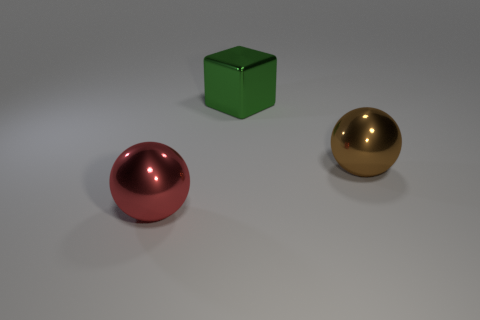How many metallic things are either large green things or purple cubes?
Your answer should be very brief. 1. Is the shape of the big brown thing the same as the big red shiny object?
Provide a succinct answer. Yes. How many big things are brown spheres or cyan blocks?
Your answer should be very brief. 1. There is a big block; are there any large shiny balls left of it?
Your response must be concise. Yes. Are there the same number of brown shiny spheres that are on the right side of the red metal ball and big brown things?
Provide a succinct answer. Yes. There is a large brown metal object; does it have the same shape as the large thing left of the big green cube?
Ensure brevity in your answer.  Yes. Is the number of red shiny things on the right side of the red metal sphere the same as the number of large spheres in front of the big brown metallic object?
Offer a terse response. No. There is another metal object that is the same shape as the red object; what color is it?
Provide a succinct answer. Brown. How many other large cubes are the same color as the big block?
Provide a short and direct response. 0. Is the shape of the large thing on the right side of the large shiny block the same as  the green metal object?
Provide a succinct answer. No. 